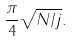<formula> <loc_0><loc_0><loc_500><loc_500>\frac { \pi } { 4 } \sqrt { N / j } .</formula> 